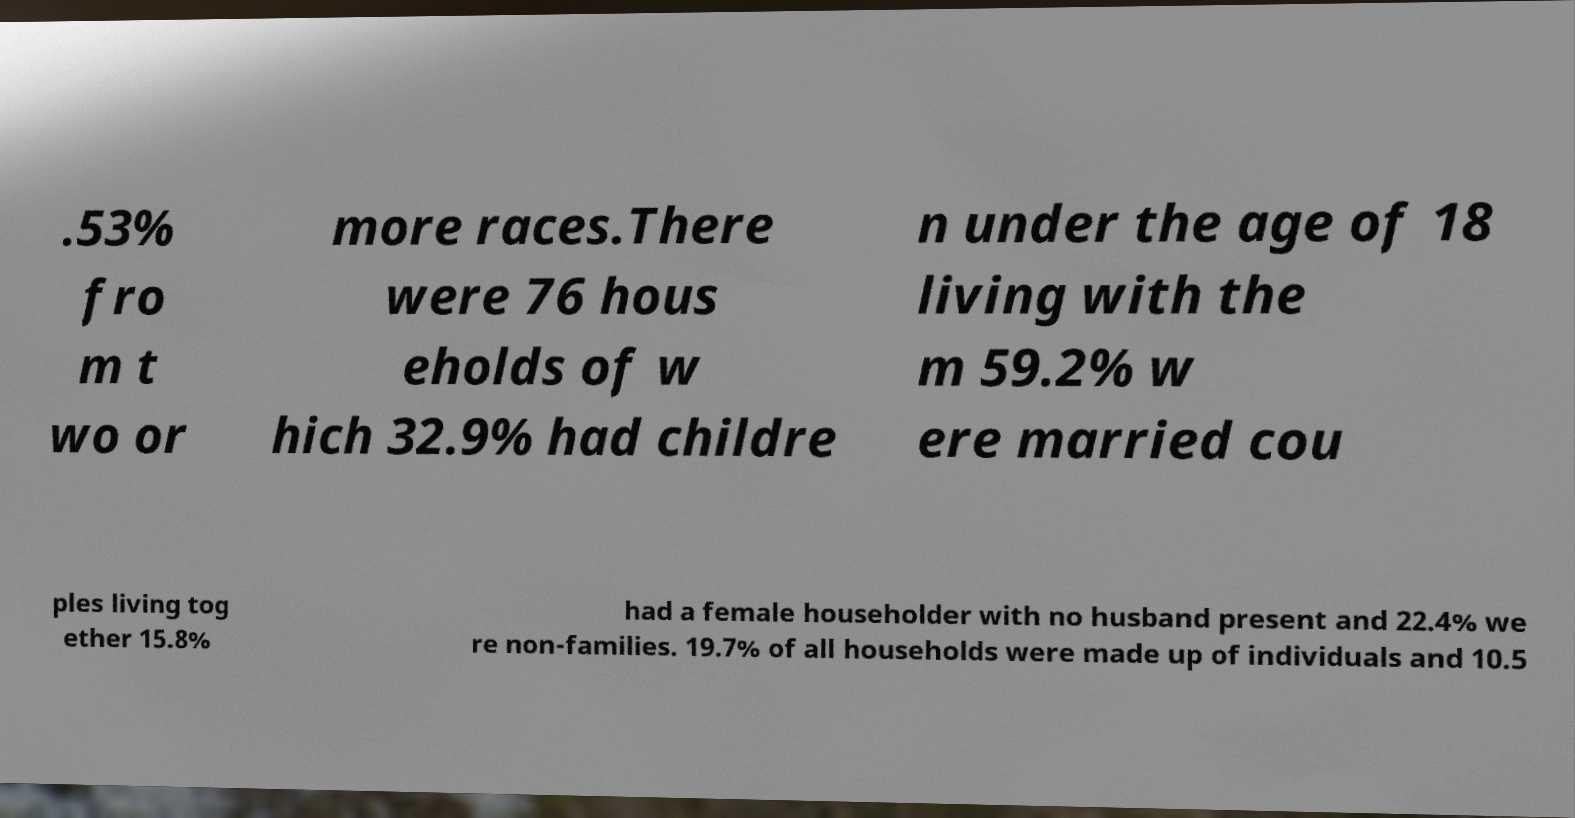There's text embedded in this image that I need extracted. Can you transcribe it verbatim? .53% fro m t wo or more races.There were 76 hous eholds of w hich 32.9% had childre n under the age of 18 living with the m 59.2% w ere married cou ples living tog ether 15.8% had a female householder with no husband present and 22.4% we re non-families. 19.7% of all households were made up of individuals and 10.5 